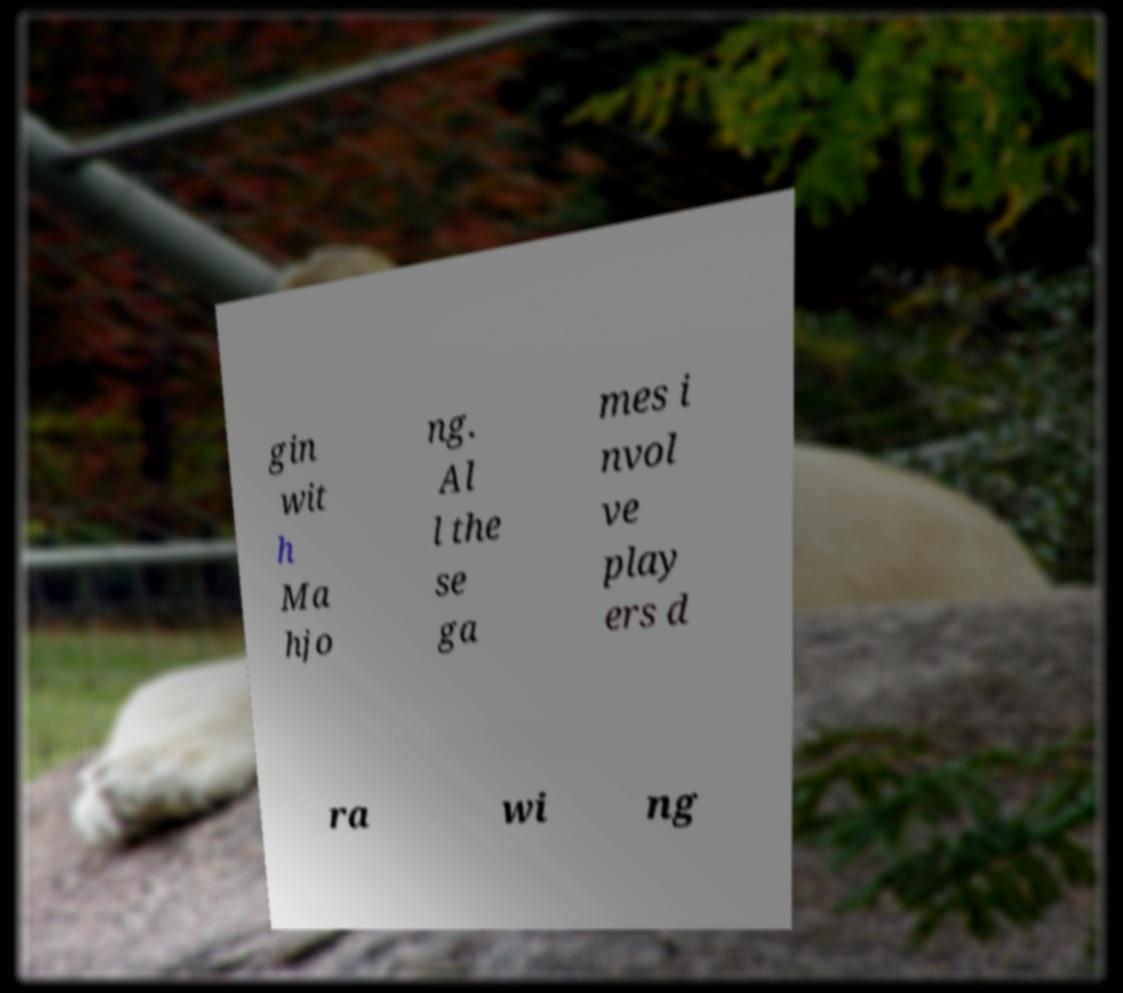Can you accurately transcribe the text from the provided image for me? gin wit h Ma hjo ng. Al l the se ga mes i nvol ve play ers d ra wi ng 